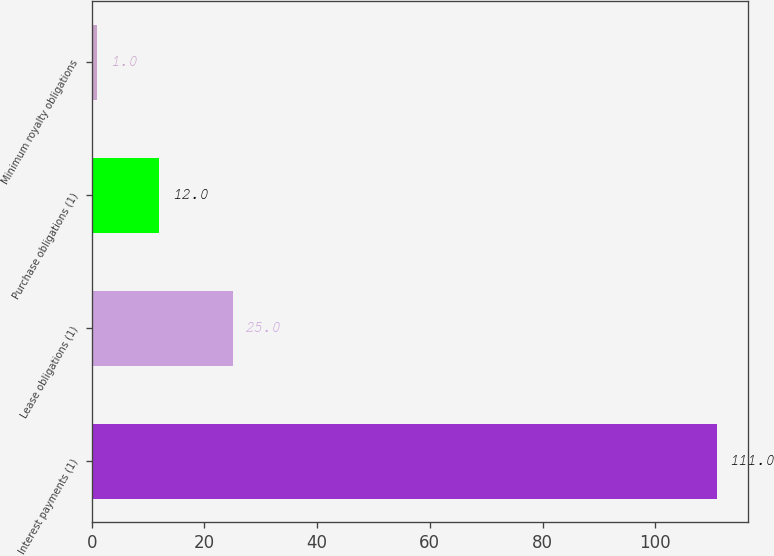<chart> <loc_0><loc_0><loc_500><loc_500><bar_chart><fcel>Interest payments (1)<fcel>Lease obligations (1)<fcel>Purchase obligations (1)<fcel>Minimum royalty obligations<nl><fcel>111<fcel>25<fcel>12<fcel>1<nl></chart> 